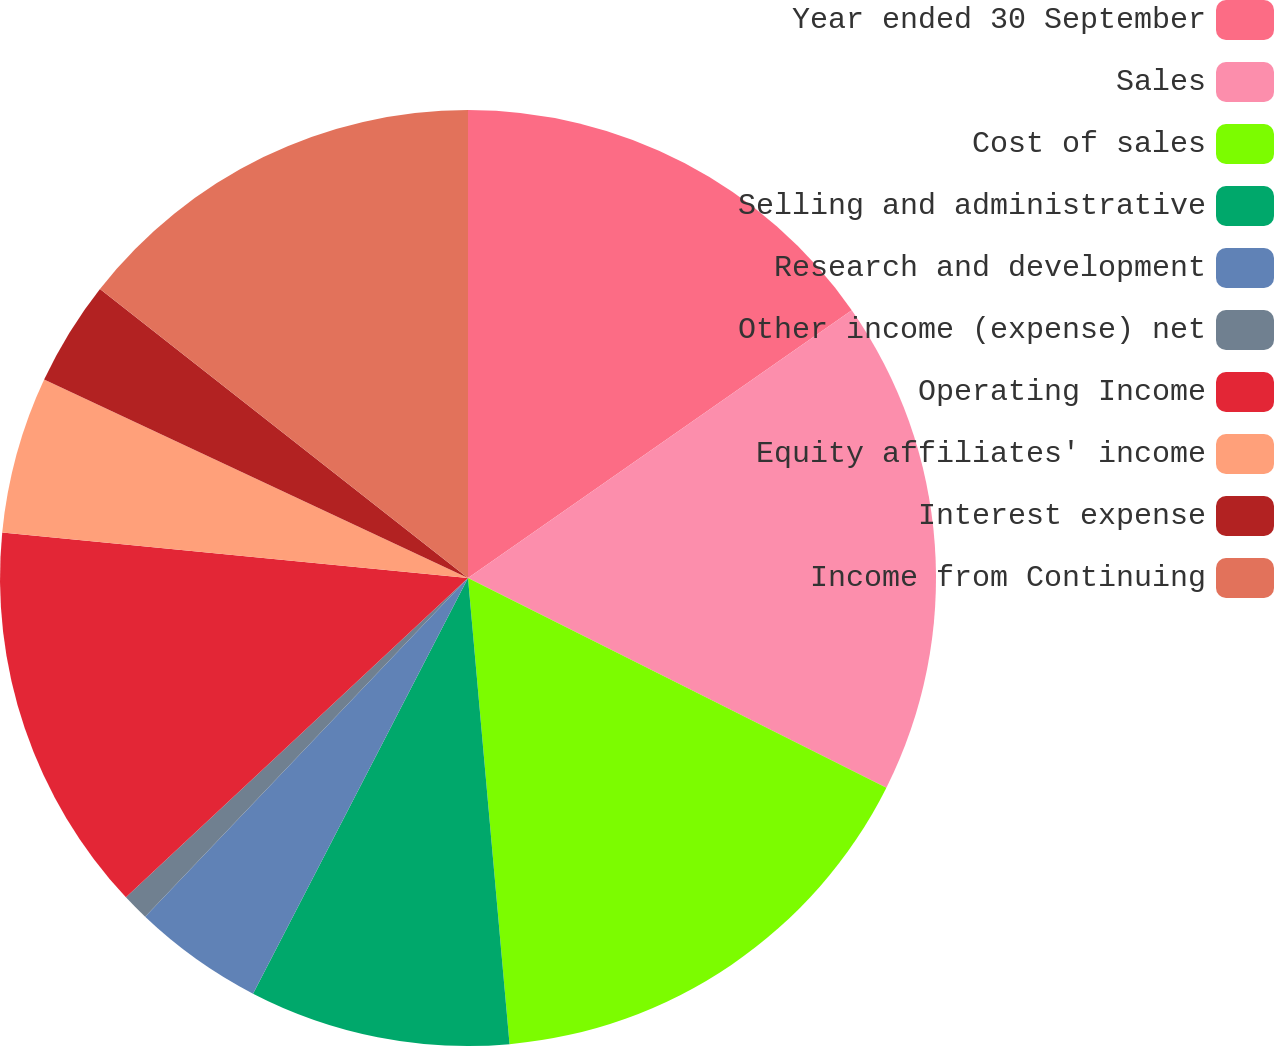<chart> <loc_0><loc_0><loc_500><loc_500><pie_chart><fcel>Year ended 30 September<fcel>Sales<fcel>Cost of sales<fcel>Selling and administrative<fcel>Research and development<fcel>Other income (expense) net<fcel>Operating Income<fcel>Equity affiliates' income<fcel>Interest expense<fcel>Income from Continuing<nl><fcel>15.3%<fcel>17.09%<fcel>16.19%<fcel>9.01%<fcel>4.52%<fcel>0.93%<fcel>13.5%<fcel>5.42%<fcel>3.63%<fcel>14.4%<nl></chart> 